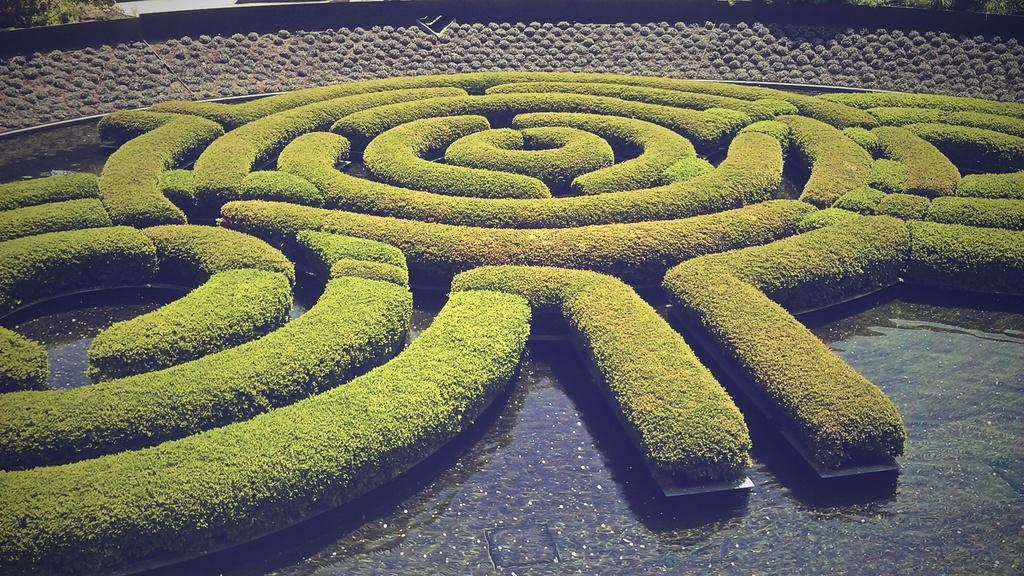What type of plants are in the water in the image? There are plants in the water in the image. What can be seen in the background of the image? There is a wall visible in the image. What type of punishment is being given to the babies in the image? There are no babies present in the image, so it is not possible to determine if any punishment is being given. 